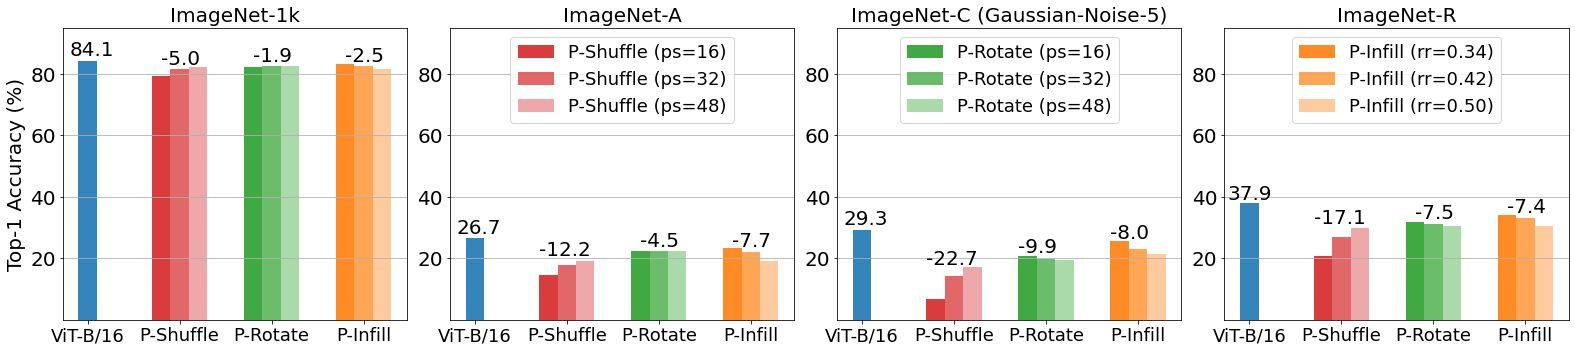Which perturbation technique results in the least performance degradation for ViT-B/16 on ImageNet-C with Gaussian-Noise-5? A) P-Shuffle with ps=16 B) P-Rotate with ps=32 C) P-Rotate with ps=16 D) P-Infill with rr=0.50 The graph indicates that the P-Rotate with ps=16 (light green bar) has the smallest decrease in performance compared to the other perturbation techniques applied to ViT-B/16 in the presence of Gaussian-Noise-5 on ImageNet-C. Therefore, the correct answer is C. 